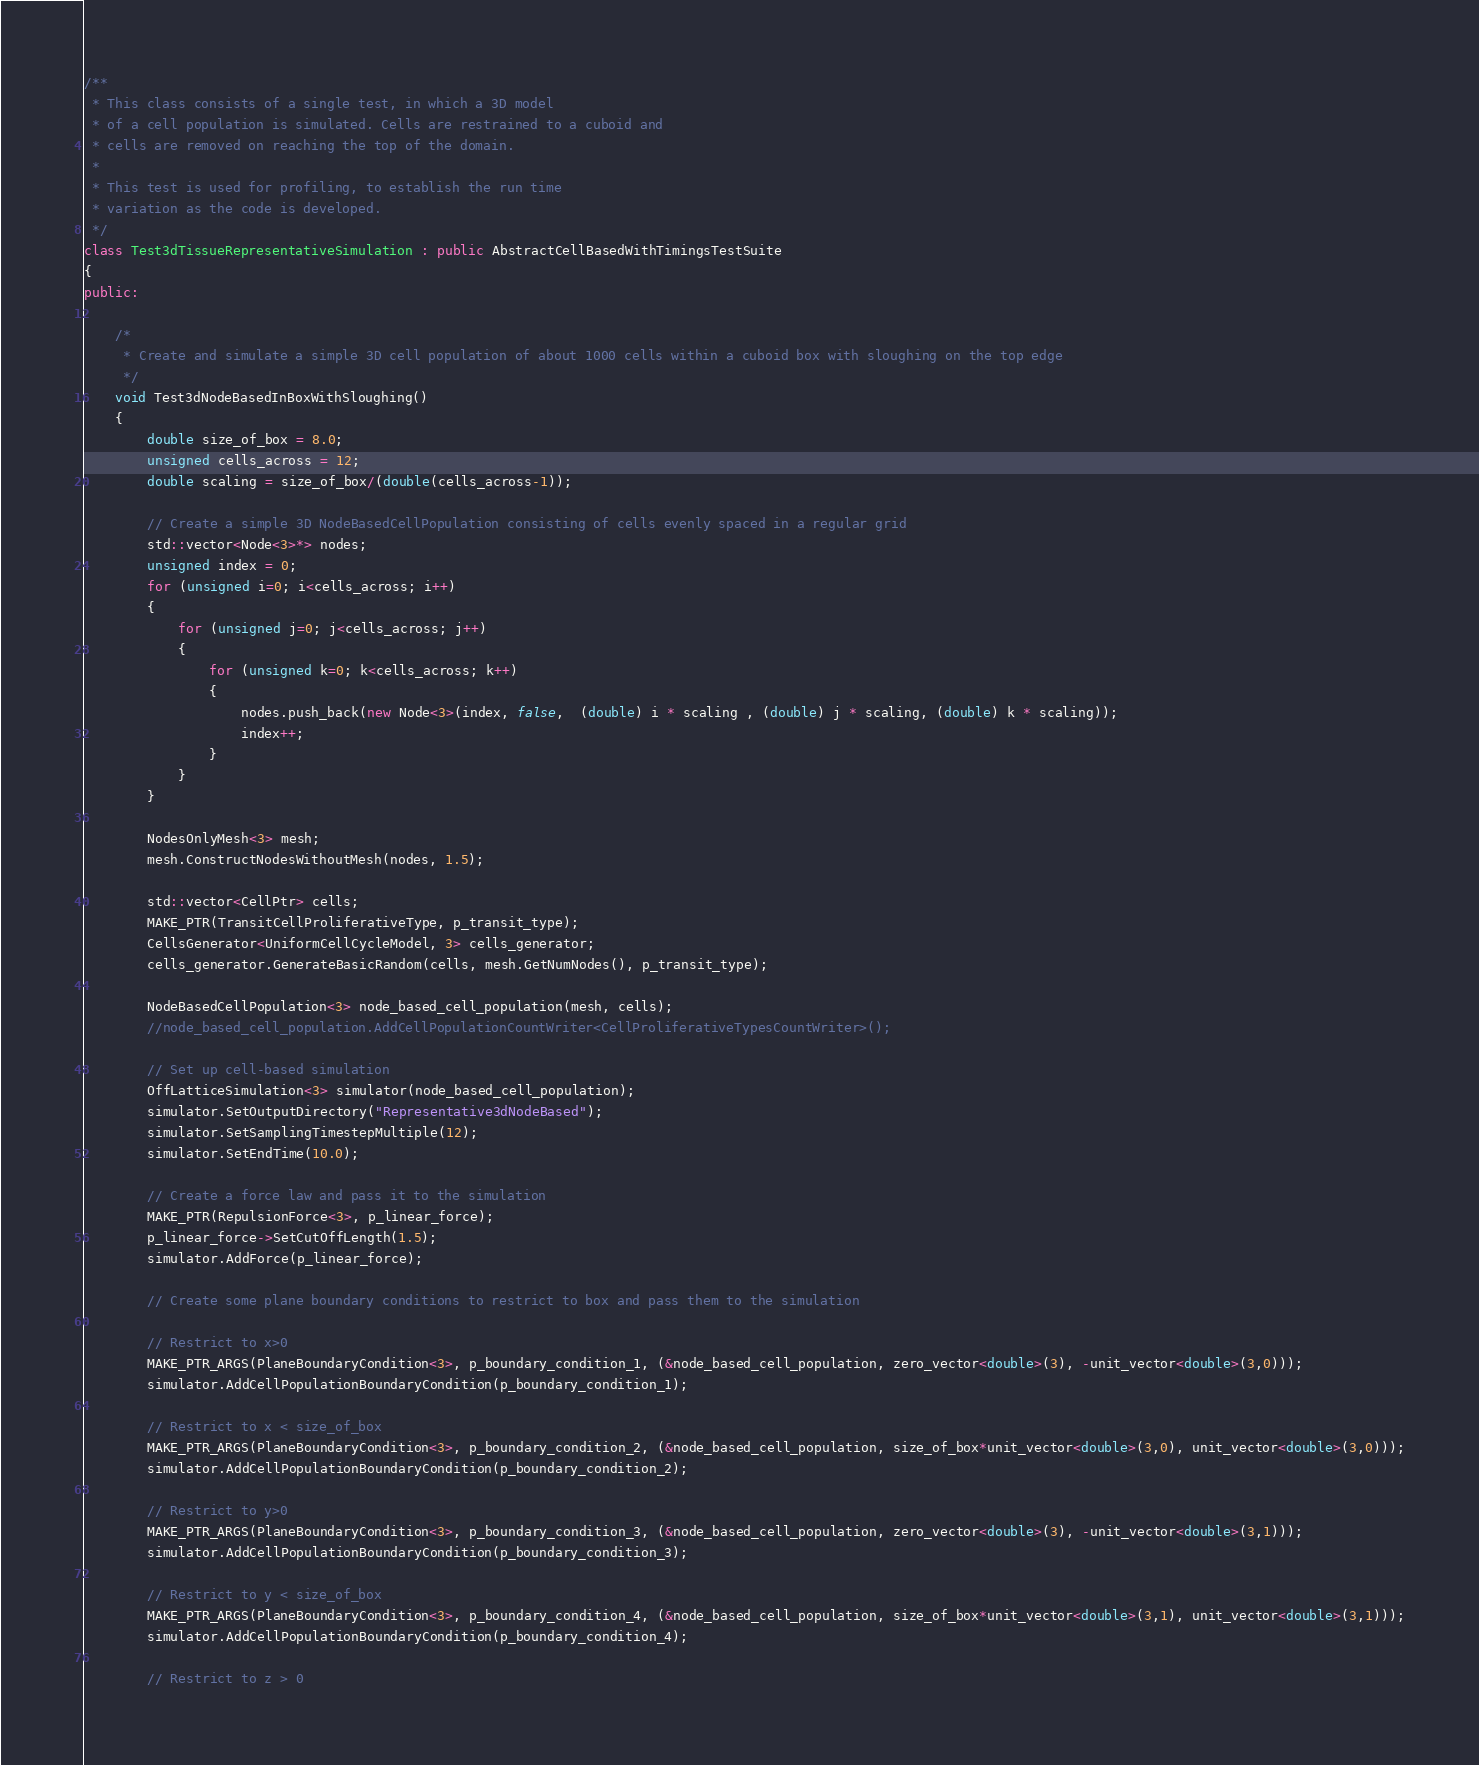<code> <loc_0><loc_0><loc_500><loc_500><_C++_>/**
 * This class consists of a single test, in which a 3D model
 * of a cell population is simulated. Cells are restrained to a cuboid and
 * cells are removed on reaching the top of the domain.
 *
 * This test is used for profiling, to establish the run time
 * variation as the code is developed.
 */
class Test3dTissueRepresentativeSimulation : public AbstractCellBasedWithTimingsTestSuite
{
public:

    /*
     * Create and simulate a simple 3D cell population of about 1000 cells within a cuboid box with sloughing on the top edge
     */
    void Test3dNodeBasedInBoxWithSloughing()
    {
        double size_of_box = 8.0;
        unsigned cells_across = 12;
        double scaling = size_of_box/(double(cells_across-1));

        // Create a simple 3D NodeBasedCellPopulation consisting of cells evenly spaced in a regular grid
        std::vector<Node<3>*> nodes;
        unsigned index = 0;
        for (unsigned i=0; i<cells_across; i++)
        {
            for (unsigned j=0; j<cells_across; j++)
            {
                for (unsigned k=0; k<cells_across; k++)
                {
                    nodes.push_back(new Node<3>(index, false,  (double) i * scaling , (double) j * scaling, (double) k * scaling));
                    index++;
                }
            }
        }

        NodesOnlyMesh<3> mesh;
        mesh.ConstructNodesWithoutMesh(nodes, 1.5);

        std::vector<CellPtr> cells;
        MAKE_PTR(TransitCellProliferativeType, p_transit_type);
        CellsGenerator<UniformCellCycleModel, 3> cells_generator;
        cells_generator.GenerateBasicRandom(cells, mesh.GetNumNodes(), p_transit_type);

        NodeBasedCellPopulation<3> node_based_cell_population(mesh, cells);
        //node_based_cell_population.AddCellPopulationCountWriter<CellProliferativeTypesCountWriter>();

        // Set up cell-based simulation
        OffLatticeSimulation<3> simulator(node_based_cell_population);
        simulator.SetOutputDirectory("Representative3dNodeBased");
        simulator.SetSamplingTimestepMultiple(12);
        simulator.SetEndTime(10.0);

        // Create a force law and pass it to the simulation
        MAKE_PTR(RepulsionForce<3>, p_linear_force);
        p_linear_force->SetCutOffLength(1.5);
        simulator.AddForce(p_linear_force);

        // Create some plane boundary conditions to restrict to box and pass them to the simulation

        // Restrict to x>0
        MAKE_PTR_ARGS(PlaneBoundaryCondition<3>, p_boundary_condition_1, (&node_based_cell_population, zero_vector<double>(3), -unit_vector<double>(3,0)));
        simulator.AddCellPopulationBoundaryCondition(p_boundary_condition_1);

        // Restrict to x < size_of_box
        MAKE_PTR_ARGS(PlaneBoundaryCondition<3>, p_boundary_condition_2, (&node_based_cell_population, size_of_box*unit_vector<double>(3,0), unit_vector<double>(3,0)));
        simulator.AddCellPopulationBoundaryCondition(p_boundary_condition_2);

        // Restrict to y>0
        MAKE_PTR_ARGS(PlaneBoundaryCondition<3>, p_boundary_condition_3, (&node_based_cell_population, zero_vector<double>(3), -unit_vector<double>(3,1)));
        simulator.AddCellPopulationBoundaryCondition(p_boundary_condition_3);

        // Restrict to y < size_of_box
        MAKE_PTR_ARGS(PlaneBoundaryCondition<3>, p_boundary_condition_4, (&node_based_cell_population, size_of_box*unit_vector<double>(3,1), unit_vector<double>(3,1)));
        simulator.AddCellPopulationBoundaryCondition(p_boundary_condition_4);

        // Restrict to z > 0</code> 